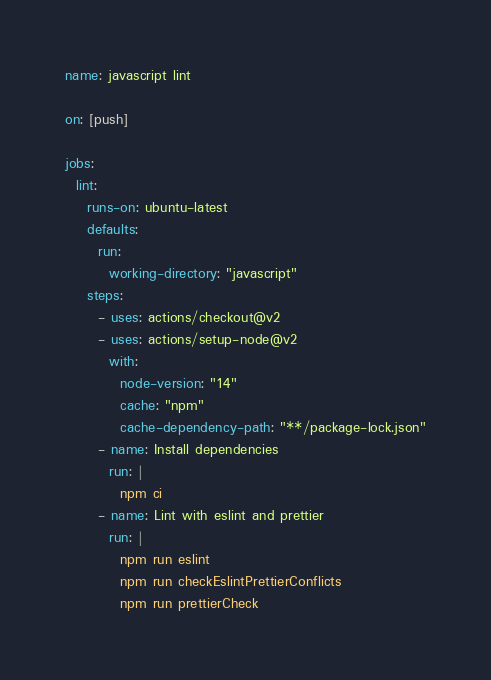Convert code to text. <code><loc_0><loc_0><loc_500><loc_500><_YAML_>name: javascript lint

on: [push]

jobs:
  lint:
    runs-on: ubuntu-latest
    defaults:
      run:
        working-directory: "javascript"
    steps:
      - uses: actions/checkout@v2
      - uses: actions/setup-node@v2
        with:
          node-version: "14"
          cache: "npm"
          cache-dependency-path: "**/package-lock.json"
      - name: Install dependencies
        run: |
          npm ci
      - name: Lint with eslint and prettier
        run: |
          npm run eslint
          npm run checkEslintPrettierConflicts
          npm run prettierCheck
</code> 